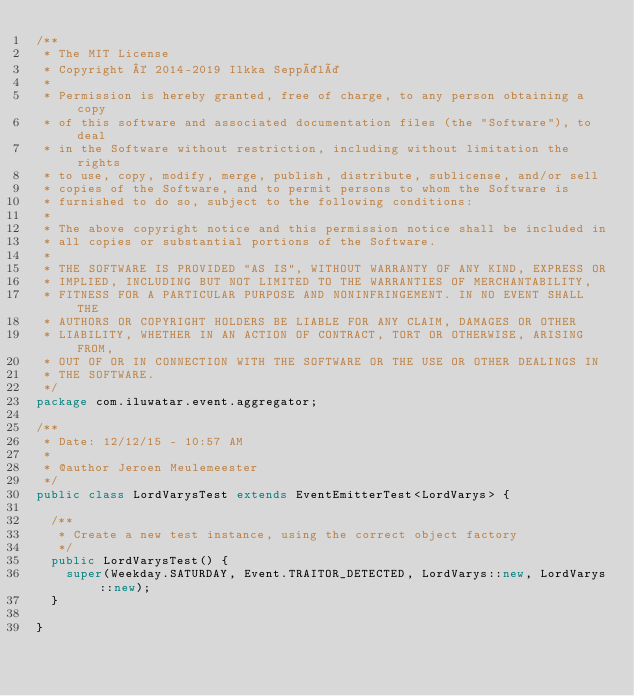<code> <loc_0><loc_0><loc_500><loc_500><_Java_>/**
 * The MIT License
 * Copyright © 2014-2019 Ilkka Seppälä
 *
 * Permission is hereby granted, free of charge, to any person obtaining a copy
 * of this software and associated documentation files (the "Software"), to deal
 * in the Software without restriction, including without limitation the rights
 * to use, copy, modify, merge, publish, distribute, sublicense, and/or sell
 * copies of the Software, and to permit persons to whom the Software is
 * furnished to do so, subject to the following conditions:
 *
 * The above copyright notice and this permission notice shall be included in
 * all copies or substantial portions of the Software.
 *
 * THE SOFTWARE IS PROVIDED "AS IS", WITHOUT WARRANTY OF ANY KIND, EXPRESS OR
 * IMPLIED, INCLUDING BUT NOT LIMITED TO THE WARRANTIES OF MERCHANTABILITY,
 * FITNESS FOR A PARTICULAR PURPOSE AND NONINFRINGEMENT. IN NO EVENT SHALL THE
 * AUTHORS OR COPYRIGHT HOLDERS BE LIABLE FOR ANY CLAIM, DAMAGES OR OTHER
 * LIABILITY, WHETHER IN AN ACTION OF CONTRACT, TORT OR OTHERWISE, ARISING FROM,
 * OUT OF OR IN CONNECTION WITH THE SOFTWARE OR THE USE OR OTHER DEALINGS IN
 * THE SOFTWARE.
 */
package com.iluwatar.event.aggregator;

/**
 * Date: 12/12/15 - 10:57 AM
 *
 * @author Jeroen Meulemeester
 */
public class LordVarysTest extends EventEmitterTest<LordVarys> {

  /**
   * Create a new test instance, using the correct object factory
   */
  public LordVarysTest() {
    super(Weekday.SATURDAY, Event.TRAITOR_DETECTED, LordVarys::new, LordVarys::new);
  }

}</code> 